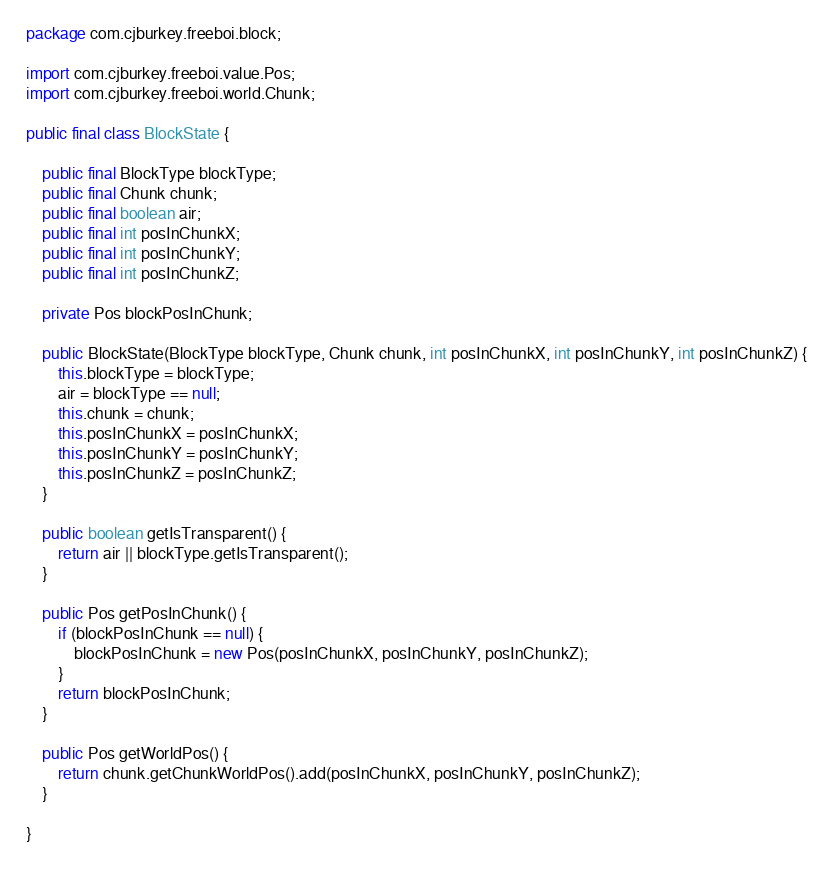<code> <loc_0><loc_0><loc_500><loc_500><_Java_>package com.cjburkey.freeboi.block;

import com.cjburkey.freeboi.value.Pos;
import com.cjburkey.freeboi.world.Chunk;

public final class BlockState {
    
    public final BlockType blockType;
    public final Chunk chunk;
    public final boolean air;
    public final int posInChunkX;
    public final int posInChunkY;
    public final int posInChunkZ;
    
    private Pos blockPosInChunk;
    
    public BlockState(BlockType blockType, Chunk chunk, int posInChunkX, int posInChunkY, int posInChunkZ) {
        this.blockType = blockType;
        air = blockType == null;
        this.chunk = chunk;
        this.posInChunkX = posInChunkX;
        this.posInChunkY = posInChunkY;
        this.posInChunkZ = posInChunkZ;
    }
    
    public boolean getIsTransparent() {
        return air || blockType.getIsTransparent();
    }
    
    public Pos getPosInChunk() {
        if (blockPosInChunk == null) {
            blockPosInChunk = new Pos(posInChunkX, posInChunkY, posInChunkZ);
        }
        return blockPosInChunk;
    }
    
    public Pos getWorldPos() {
        return chunk.getChunkWorldPos().add(posInChunkX, posInChunkY, posInChunkZ);
    }
    
}
</code> 